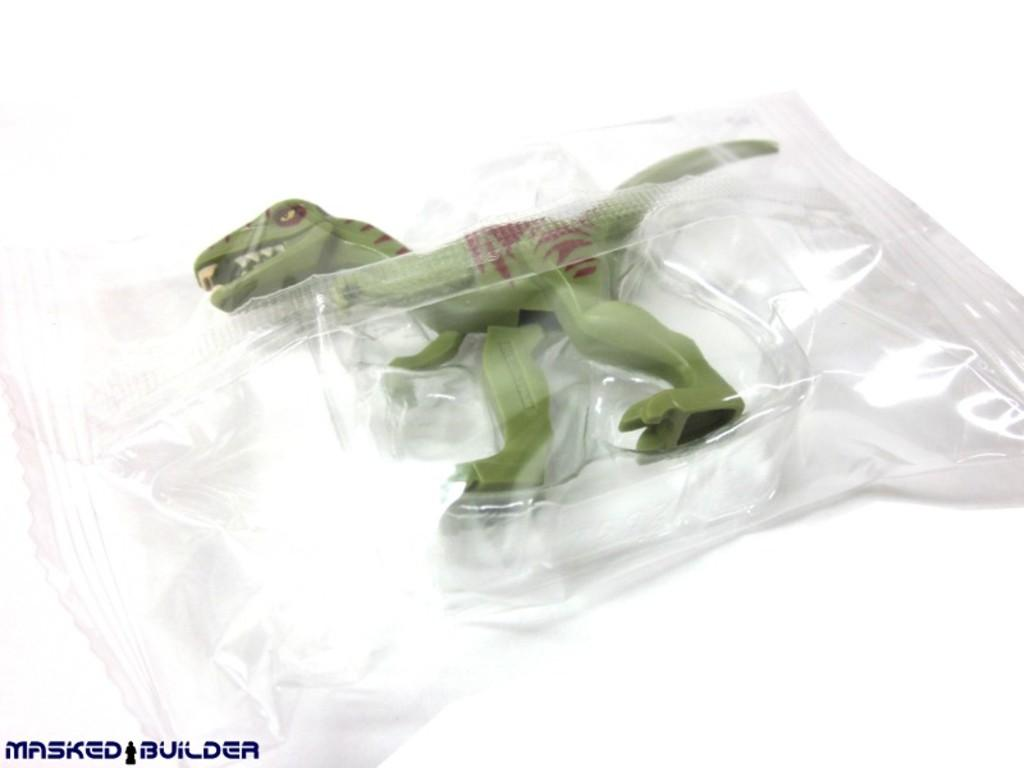What is the main subject of the image? The main subject of the image is a toy dinosaur. What color is the toy dinosaur? The toy dinosaur is green in color. How is the toy dinosaur being displayed or presented? The toy is packaged in a cover. What color is the background of the image? The background appears white in color. What type of sign can be seen in the image? There is no sign present in the image; it features a toy dinosaur packaged in a cover with a white background. Can you describe the wings of the toy dinosaur in the image? The toy dinosaur in the image does not have wings, as it is a representation of a prehistoric creature that did not possess wings. 